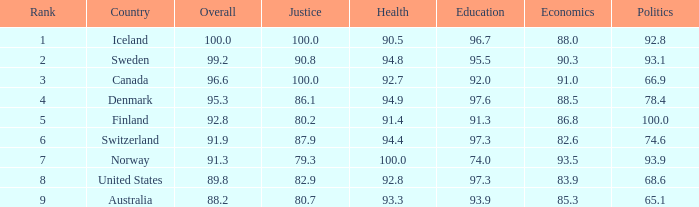8? 90.3. Would you mind parsing the complete table? {'header': ['Rank', 'Country', 'Overall', 'Justice', 'Health', 'Education', 'Economics', 'Politics'], 'rows': [['1', 'Iceland', '100.0', '100.0', '90.5', '96.7', '88.0', '92.8'], ['2', 'Sweden', '99.2', '90.8', '94.8', '95.5', '90.3', '93.1'], ['3', 'Canada', '96.6', '100.0', '92.7', '92.0', '91.0', '66.9'], ['4', 'Denmark', '95.3', '86.1', '94.9', '97.6', '88.5', '78.4'], ['5', 'Finland', '92.8', '80.2', '91.4', '91.3', '86.8', '100.0'], ['6', 'Switzerland', '91.9', '87.9', '94.4', '97.3', '82.6', '74.6'], ['7', 'Norway', '91.3', '79.3', '100.0', '74.0', '93.5', '93.9'], ['8', 'United States', '89.8', '82.9', '92.8', '97.3', '83.9', '68.6'], ['9', 'Australia', '88.2', '80.7', '93.3', '93.9', '85.3', '65.1']]} 